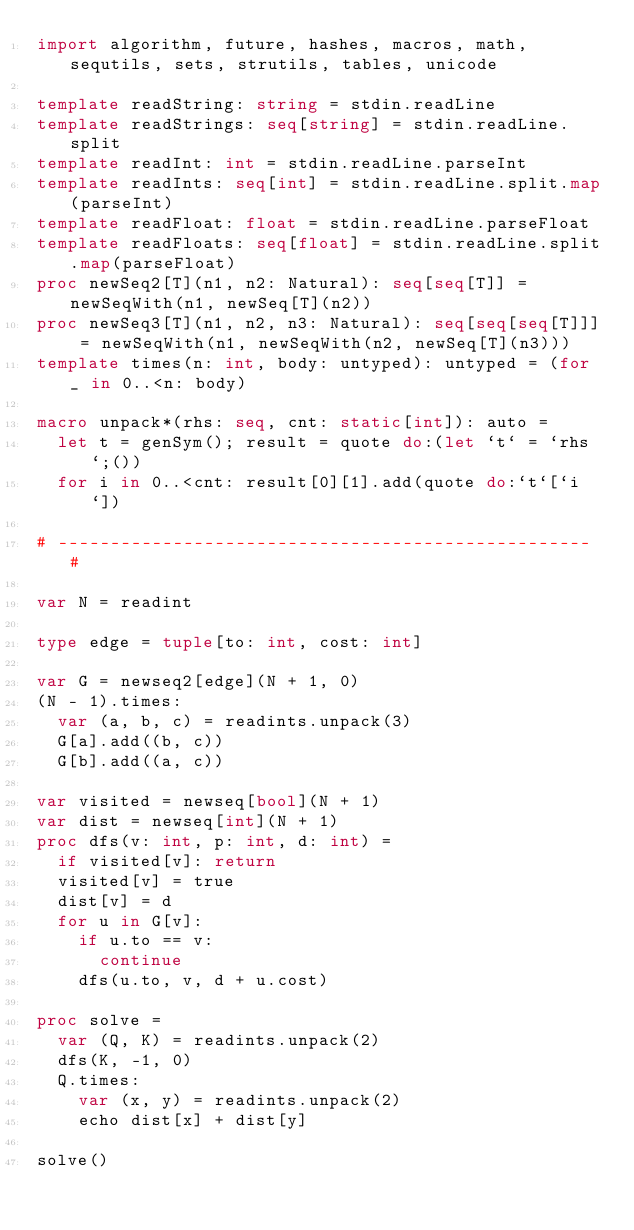Convert code to text. <code><loc_0><loc_0><loc_500><loc_500><_Nim_>import algorithm, future, hashes, macros, math, sequtils, sets, strutils, tables, unicode

template readString: string = stdin.readLine
template readStrings: seq[string] = stdin.readLine.split
template readInt: int = stdin.readLine.parseInt
template readInts: seq[int] = stdin.readLine.split.map(parseInt)
template readFloat: float = stdin.readLine.parseFloat
template readFloats: seq[float] = stdin.readLine.split.map(parseFloat)
proc newSeq2[T](n1, n2: Natural): seq[seq[T]] = newSeqWith(n1, newSeq[T](n2))
proc newSeq3[T](n1, n2, n3: Natural): seq[seq[seq[T]]] = newSeqWith(n1, newSeqWith(n2, newSeq[T](n3)))
template times(n: int, body: untyped): untyped = (for _ in 0..<n: body)

macro unpack*(rhs: seq, cnt: static[int]): auto =
  let t = genSym(); result = quote do:(let `t` = `rhs`;())
  for i in 0..<cnt: result[0][1].add(quote do:`t`[`i`])

# --------------------------------------------------- #

var N = readint

type edge = tuple[to: int, cost: int]

var G = newseq2[edge](N + 1, 0)
(N - 1).times:
  var (a, b, c) = readints.unpack(3)
  G[a].add((b, c))
  G[b].add((a, c))

var visited = newseq[bool](N + 1)
var dist = newseq[int](N + 1)
proc dfs(v: int, p: int, d: int) =
  if visited[v]: return
  visited[v] = true
  dist[v] = d
  for u in G[v]:
    if u.to == v:
      continue
    dfs(u.to, v, d + u.cost)

proc solve =
  var (Q, K) = readints.unpack(2)
  dfs(K, -1, 0)
  Q.times:
    var (x, y) = readints.unpack(2)
    echo dist[x] + dist[y]

solve()</code> 